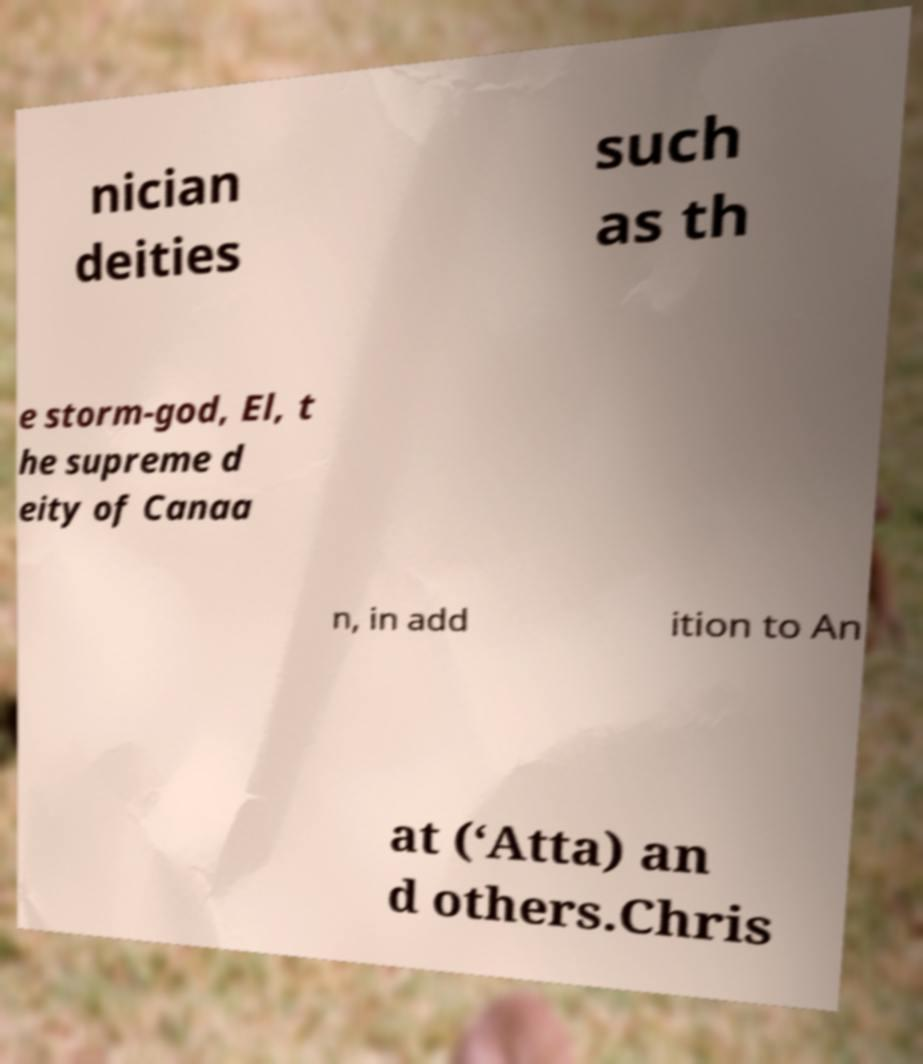Can you accurately transcribe the text from the provided image for me? nician deities such as th e storm-god, El, t he supreme d eity of Canaa n, in add ition to An at (‘Atta) an d others.Chris 